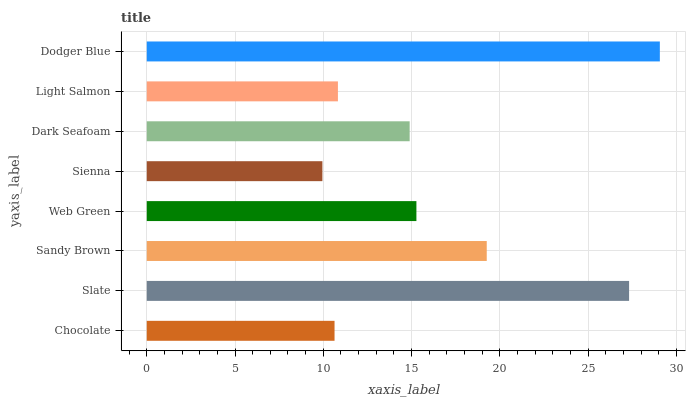Is Sienna the minimum?
Answer yes or no. Yes. Is Dodger Blue the maximum?
Answer yes or no. Yes. Is Slate the minimum?
Answer yes or no. No. Is Slate the maximum?
Answer yes or no. No. Is Slate greater than Chocolate?
Answer yes or no. Yes. Is Chocolate less than Slate?
Answer yes or no. Yes. Is Chocolate greater than Slate?
Answer yes or no. No. Is Slate less than Chocolate?
Answer yes or no. No. Is Web Green the high median?
Answer yes or no. Yes. Is Dark Seafoam the low median?
Answer yes or no. Yes. Is Chocolate the high median?
Answer yes or no. No. Is Sandy Brown the low median?
Answer yes or no. No. 